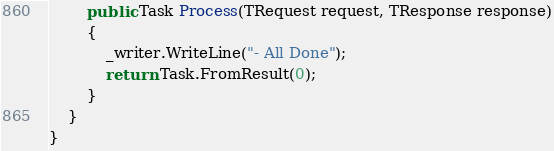Convert code to text. <code><loc_0><loc_0><loc_500><loc_500><_C#_>
        public Task Process(TRequest request, TResponse response)
        {
            _writer.WriteLine("- All Done");
            return Task.FromResult(0);
        }
    }
}</code> 